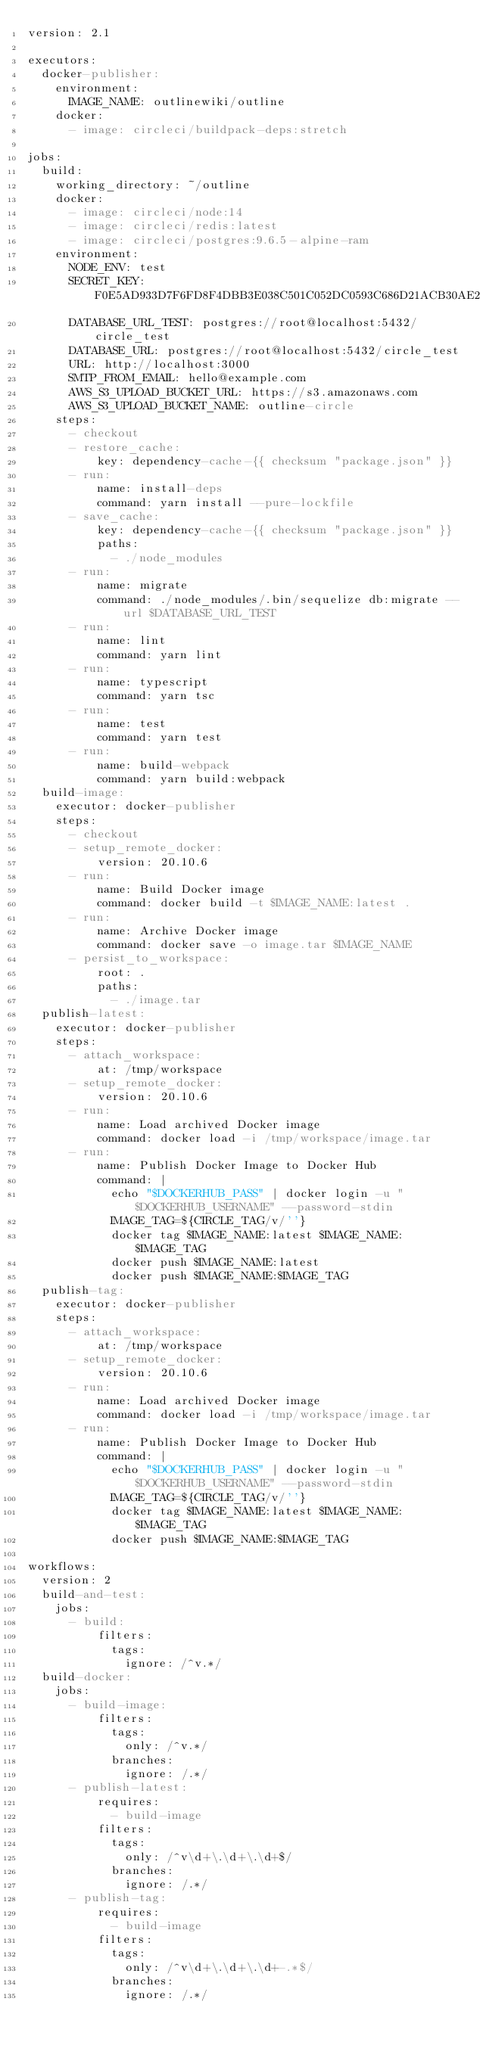<code> <loc_0><loc_0><loc_500><loc_500><_YAML_>version: 2.1

executors:
  docker-publisher:
    environment:
      IMAGE_NAME: outlinewiki/outline
    docker:
      - image: circleci/buildpack-deps:stretch

jobs:
  build:
    working_directory: ~/outline
    docker:
      - image: circleci/node:14
      - image: circleci/redis:latest
      - image: circleci/postgres:9.6.5-alpine-ram
    environment:
      NODE_ENV: test
      SECRET_KEY: F0E5AD933D7F6FD8F4DBB3E038C501C052DC0593C686D21ACB30AE205D2F634B
      DATABASE_URL_TEST: postgres://root@localhost:5432/circle_test
      DATABASE_URL: postgres://root@localhost:5432/circle_test
      URL: http://localhost:3000
      SMTP_FROM_EMAIL: hello@example.com
      AWS_S3_UPLOAD_BUCKET_URL: https://s3.amazonaws.com
      AWS_S3_UPLOAD_BUCKET_NAME: outline-circle
    steps:
      - checkout
      - restore_cache:
          key: dependency-cache-{{ checksum "package.json" }}
      - run:
          name: install-deps
          command: yarn install --pure-lockfile
      - save_cache:
          key: dependency-cache-{{ checksum "package.json" }}
          paths:
            - ./node_modules
      - run:
          name: migrate
          command: ./node_modules/.bin/sequelize db:migrate --url $DATABASE_URL_TEST
      - run:
          name: lint
          command: yarn lint
      - run:
          name: typescript
          command: yarn tsc
      - run:
          name: test
          command: yarn test
      - run:
          name: build-webpack
          command: yarn build:webpack
  build-image:
    executor: docker-publisher
    steps:
      - checkout
      - setup_remote_docker:
          version: 20.10.6
      - run:
          name: Build Docker image
          command: docker build -t $IMAGE_NAME:latest .
      - run:
          name: Archive Docker image
          command: docker save -o image.tar $IMAGE_NAME
      - persist_to_workspace:
          root: .
          paths:
            - ./image.tar
  publish-latest:
    executor: docker-publisher
    steps:
      - attach_workspace:
          at: /tmp/workspace
      - setup_remote_docker:
          version: 20.10.6
      - run:
          name: Load archived Docker image
          command: docker load -i /tmp/workspace/image.tar
      - run:
          name: Publish Docker Image to Docker Hub
          command: |
            echo "$DOCKERHUB_PASS" | docker login -u "$DOCKERHUB_USERNAME" --password-stdin
            IMAGE_TAG=${CIRCLE_TAG/v/''}
            docker tag $IMAGE_NAME:latest $IMAGE_NAME:$IMAGE_TAG
            docker push $IMAGE_NAME:latest
            docker push $IMAGE_NAME:$IMAGE_TAG
  publish-tag:
    executor: docker-publisher
    steps:
      - attach_workspace:
          at: /tmp/workspace
      - setup_remote_docker:
          version: 20.10.6
      - run:
          name: Load archived Docker image
          command: docker load -i /tmp/workspace/image.tar
      - run:
          name: Publish Docker Image to Docker Hub
          command: |
            echo "$DOCKERHUB_PASS" | docker login -u "$DOCKERHUB_USERNAME" --password-stdin
            IMAGE_TAG=${CIRCLE_TAG/v/''}
            docker tag $IMAGE_NAME:latest $IMAGE_NAME:$IMAGE_TAG
            docker push $IMAGE_NAME:$IMAGE_TAG

workflows:
  version: 2
  build-and-test:
    jobs:
      - build:
          filters:
            tags:
              ignore: /^v.*/
  build-docker:
    jobs:
      - build-image:
          filters:
            tags:
              only: /^v.*/
            branches:
              ignore: /.*/
      - publish-latest:
          requires:
            - build-image
          filters:
            tags:
              only: /^v\d+\.\d+\.\d+$/
            branches:
              ignore: /.*/
      - publish-tag:
          requires:
            - build-image
          filters:
            tags:
              only: /^v\d+\.\d+\.\d+-.*$/
            branches:
              ignore: /.*/
</code> 